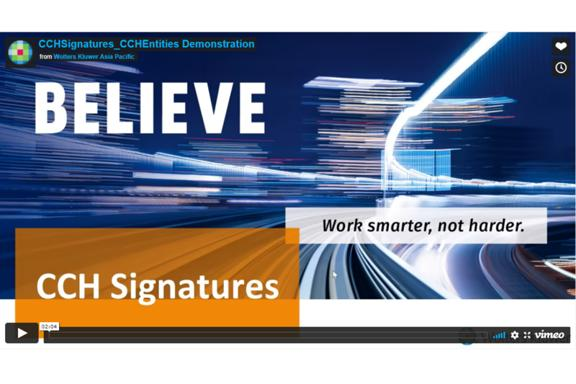What is the organization associated with the demonstration? The organization linked to this demonstration is Wolters Kluwer Asia Pacific, which is known for providing expert solutions, software, and services in healthcare, tax, accounting, finance, and legal sectors. 